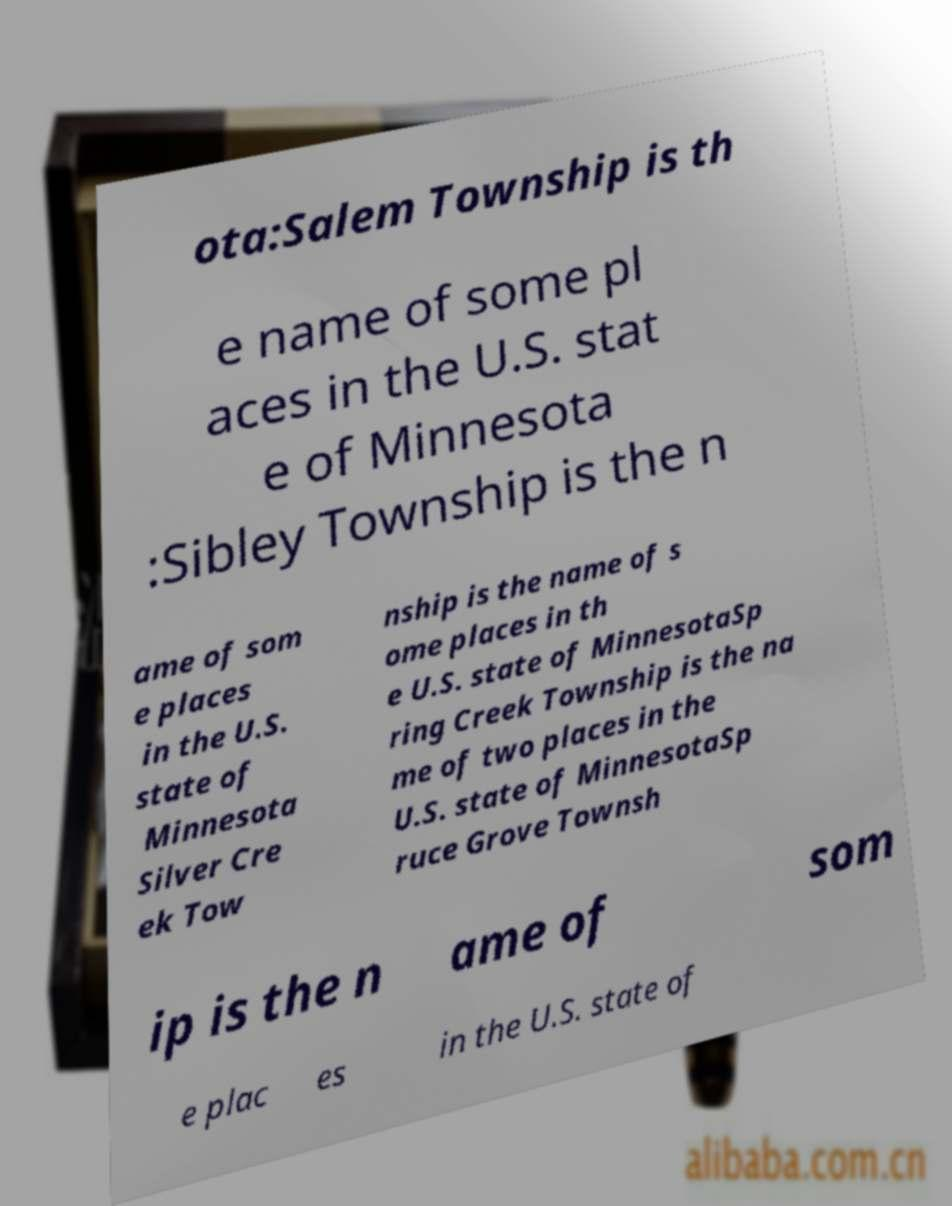Can you accurately transcribe the text from the provided image for me? ota:Salem Township is th e name of some pl aces in the U.S. stat e of Minnesota :Sibley Township is the n ame of som e places in the U.S. state of Minnesota Silver Cre ek Tow nship is the name of s ome places in th e U.S. state of MinnesotaSp ring Creek Township is the na me of two places in the U.S. state of MinnesotaSp ruce Grove Townsh ip is the n ame of som e plac es in the U.S. state of 